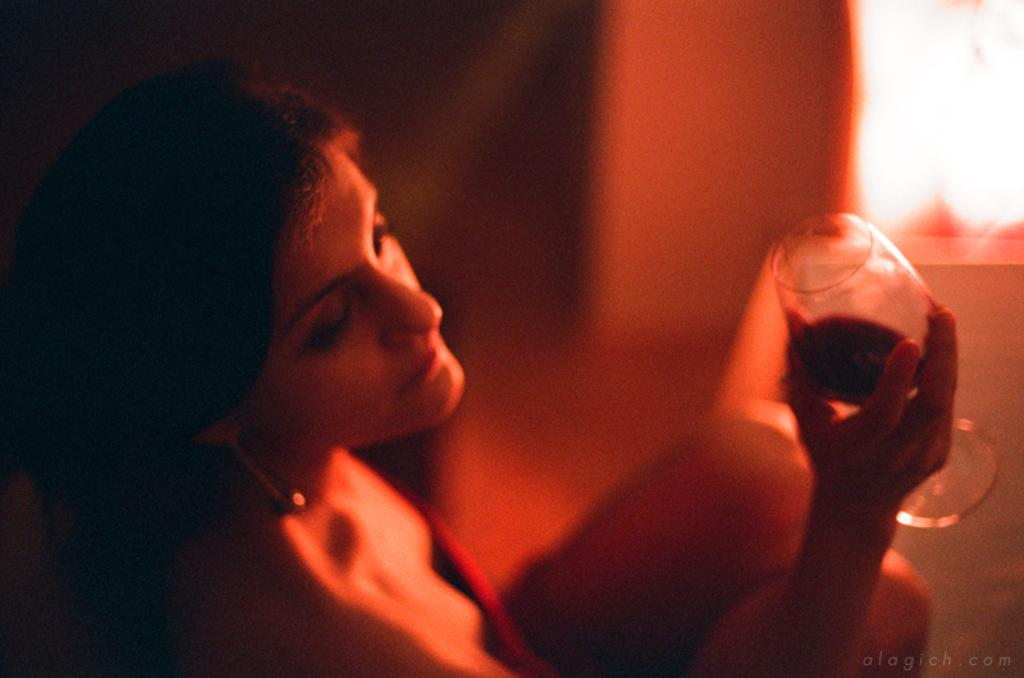Who is present in the image? There is a woman in the image. What is the woman holding in the image? The woman is holding a glass. What is inside the glass? The glass contains a drink. What is the dominant color of the image? The image is in red color. What type of scientific experiment is being conducted in the image? There is no scientific experiment present in the image; it features a woman holding a glass with a drink. How does the image promote peace? The image does not specifically promote peace; it simply shows a woman holding a glass with a drink. 